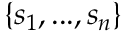<formula> <loc_0><loc_0><loc_500><loc_500>\{ s _ { 1 } , \dots , s _ { n } \}</formula> 